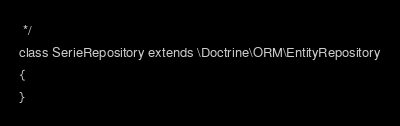<code> <loc_0><loc_0><loc_500><loc_500><_PHP_> */
class SerieRepository extends \Doctrine\ORM\EntityRepository
{
}
</code> 